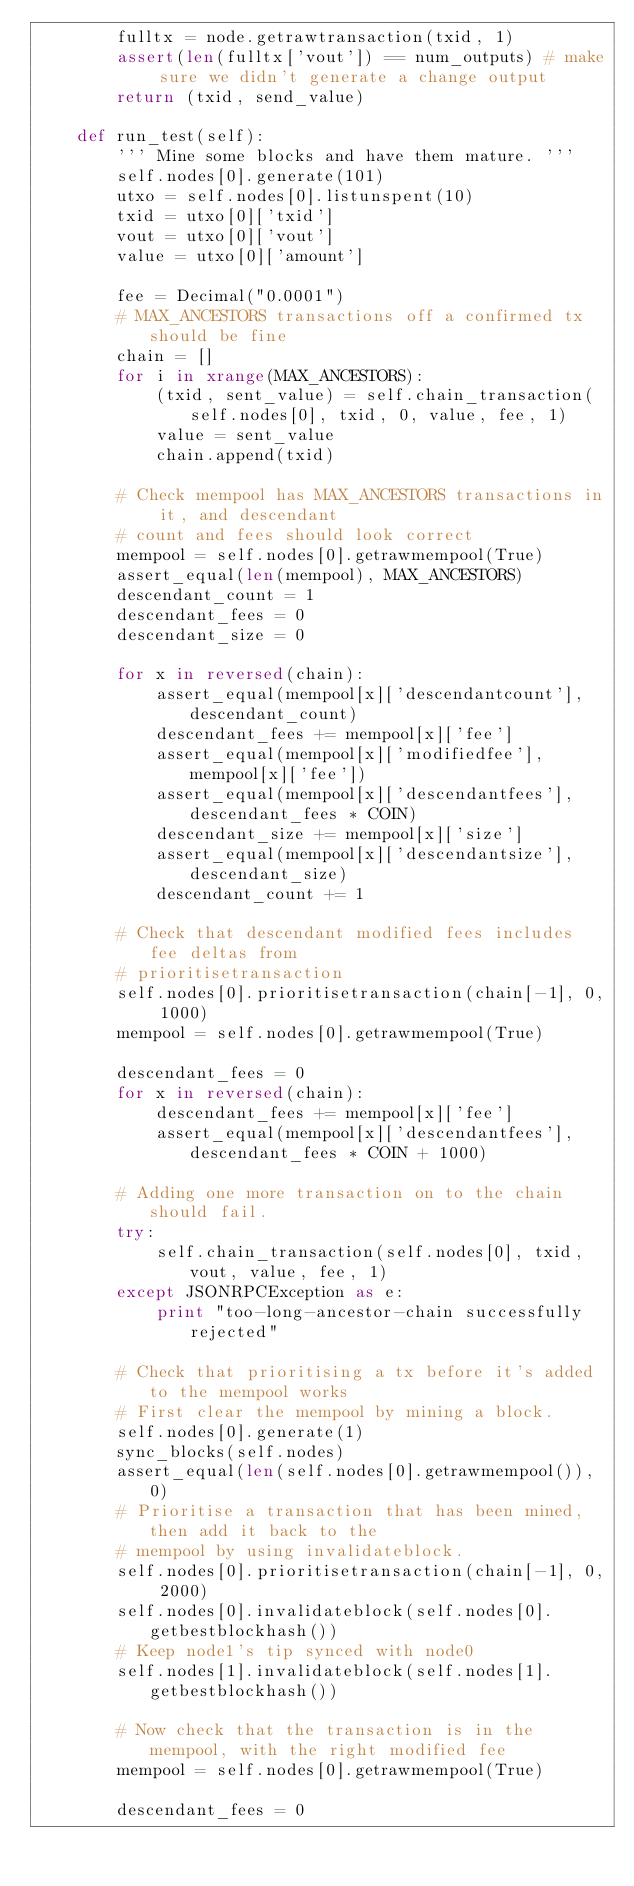Convert code to text. <code><loc_0><loc_0><loc_500><loc_500><_Python_>        fulltx = node.getrawtransaction(txid, 1)
        assert(len(fulltx['vout']) == num_outputs) # make sure we didn't generate a change output
        return (txid, send_value)

    def run_test(self):
        ''' Mine some blocks and have them mature. '''
        self.nodes[0].generate(101)
        utxo = self.nodes[0].listunspent(10)
        txid = utxo[0]['txid']
        vout = utxo[0]['vout']
        value = utxo[0]['amount']

        fee = Decimal("0.0001")
        # MAX_ANCESTORS transactions off a confirmed tx should be fine
        chain = []
        for i in xrange(MAX_ANCESTORS):
            (txid, sent_value) = self.chain_transaction(self.nodes[0], txid, 0, value, fee, 1)
            value = sent_value
            chain.append(txid)

        # Check mempool has MAX_ANCESTORS transactions in it, and descendant
        # count and fees should look correct
        mempool = self.nodes[0].getrawmempool(True)
        assert_equal(len(mempool), MAX_ANCESTORS)
        descendant_count = 1
        descendant_fees = 0
        descendant_size = 0

        for x in reversed(chain):
            assert_equal(mempool[x]['descendantcount'], descendant_count)
            descendant_fees += mempool[x]['fee']
            assert_equal(mempool[x]['modifiedfee'], mempool[x]['fee'])
            assert_equal(mempool[x]['descendantfees'], descendant_fees * COIN)
            descendant_size += mempool[x]['size']
            assert_equal(mempool[x]['descendantsize'], descendant_size)
            descendant_count += 1

        # Check that descendant modified fees includes fee deltas from
        # prioritisetransaction
        self.nodes[0].prioritisetransaction(chain[-1], 0, 1000)
        mempool = self.nodes[0].getrawmempool(True)

        descendant_fees = 0
        for x in reversed(chain):
            descendant_fees += mempool[x]['fee']
            assert_equal(mempool[x]['descendantfees'], descendant_fees * COIN + 1000)

        # Adding one more transaction on to the chain should fail.
        try:
            self.chain_transaction(self.nodes[0], txid, vout, value, fee, 1)
        except JSONRPCException as e:
            print "too-long-ancestor-chain successfully rejected"

        # Check that prioritising a tx before it's added to the mempool works
        # First clear the mempool by mining a block.
        self.nodes[0].generate(1)
        sync_blocks(self.nodes)
        assert_equal(len(self.nodes[0].getrawmempool()), 0)
        # Prioritise a transaction that has been mined, then add it back to the
        # mempool by using invalidateblock.
        self.nodes[0].prioritisetransaction(chain[-1], 0, 2000)
        self.nodes[0].invalidateblock(self.nodes[0].getbestblockhash())
        # Keep node1's tip synced with node0
        self.nodes[1].invalidateblock(self.nodes[1].getbestblockhash())

        # Now check that the transaction is in the mempool, with the right modified fee
        mempool = self.nodes[0].getrawmempool(True)

        descendant_fees = 0</code> 